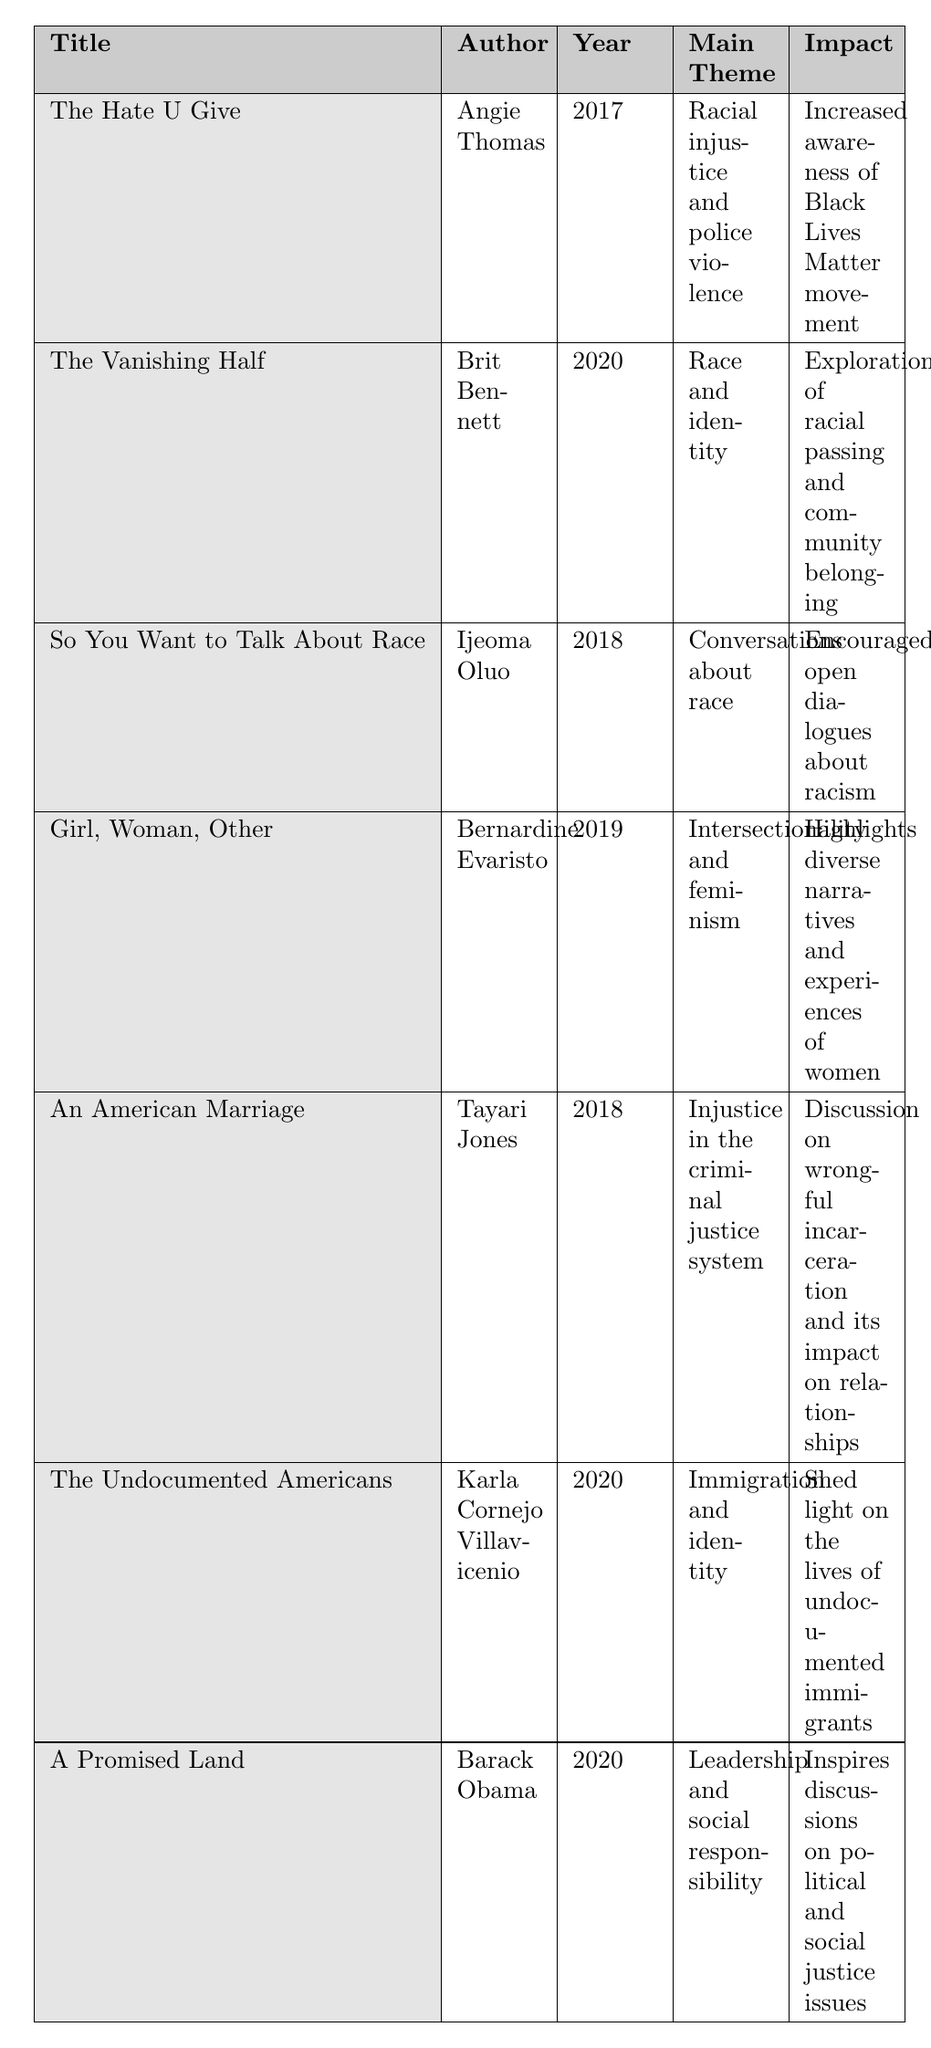What is the main theme of "The Hate U Give"? The title "The Hate U Give" appears in the table along with its corresponding main theme, which is "Racial injustice and police violence."
Answer: Racial injustice and police violence Who is the author of "Girl, Woman, Other"? The table displays the title "Girl, Woman, Other" and lists "Bernardine Evaristo" as the author in the same row.
Answer: Bernardine Evaristo In what year was "The Vanishing Half" published? The publication year for "The Vanishing Half" is indicated in the table, listed as 2020.
Answer: 2020 Which novel focuses on the theme of immigration and identity? "The Undocumented Americans" is explicitly listed in the table under the "Main Theme" as "Immigration and identity."
Answer: The Undocumented Americans Did "So You Want to Talk About Race" have a target audience of young adults? By checking the table for the target audience of "So You Want to Talk About Race," it specifies "General audience," which means it is not specifically for young adults.
Answer: No How many novels were published after 2018? The table contains entries for "The Hate U Give" (2017), "So You Want to Talk About Race" (2018), "Girl, Woman, Other" (2019), "The Vanishing Half" (2020), "The Undocumented Americans" (2020), and "A Promised Land" (2020). Excluding those published in 2018 and before, we find four novels published after 2018: "Girl, Woman, Other," "The Vanishing Half," "The Undocumented Americans," and "A Promised Land."
Answer: 4 Which book addresses intersectionality and feminism? The table indicates that "Girl, Woman, Other" is the book associated with the theme of "Intersectionality and feminism" under the "Main Theme" column.
Answer: Girl, Woman, Other What is the impact of "An American Marriage"? According to the table, the impact listed for "An American Marriage" is a "Discussion on wrongful incarceration and its impact on relationships."
Answer: Discussion on wrongful incarceration and its impact on relationships Which author wrote two books mentioned in the table? Analyzing the table, it shows that there are no repeated authors among the titles listed. Each book has a unique author.
Answer: None What is the proportion of books targeted at adults versus general audiences? From the table, there are a total of 7 books: 4 are targeted at adults ("The Vanishing Half," "Girl, Woman, Other," "An American Marriage," and "A Promised Land") and 3 are aimed at a general audience ("So You Want to Talk About Race," "The Undocumented Americans," and "A Promised Land"). Therefore, the proportion is 4:3.
Answer: 4:3 